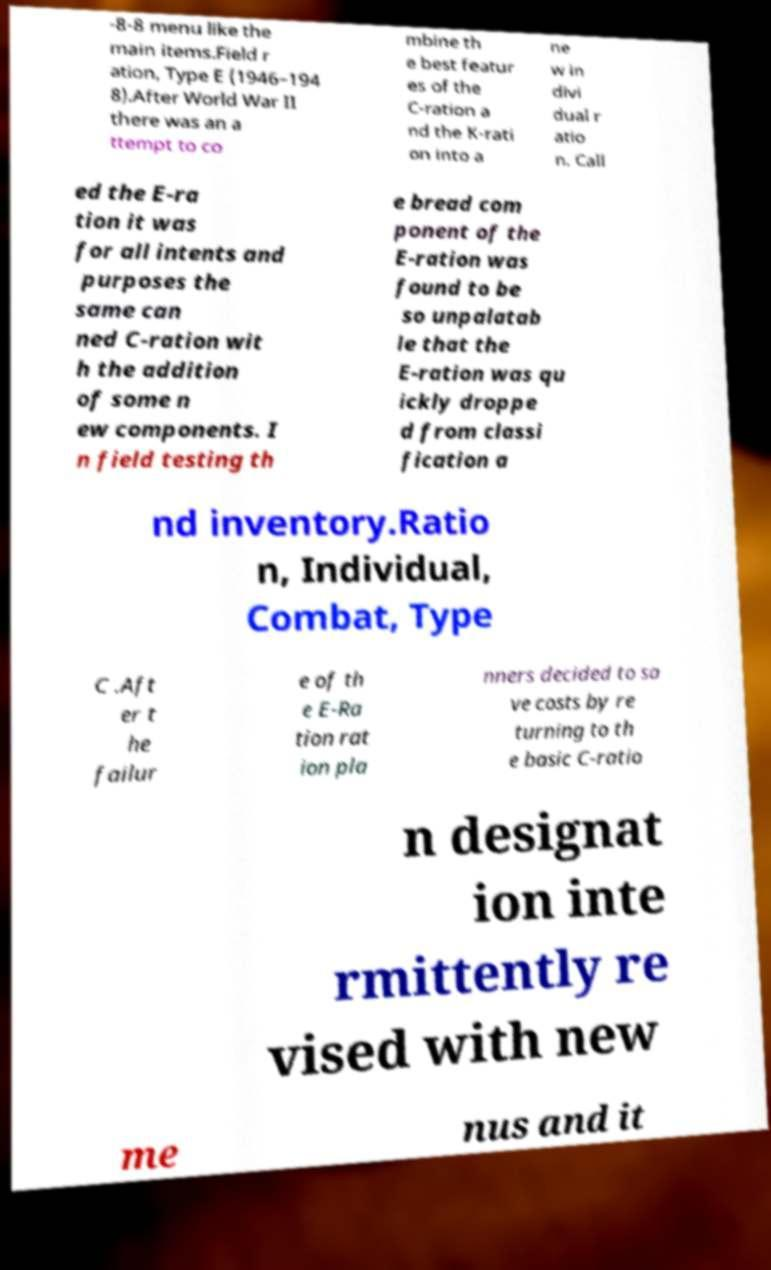I need the written content from this picture converted into text. Can you do that? -8-8 menu like the main items.Field r ation, Type E (1946–194 8).After World War II there was an a ttempt to co mbine th e best featur es of the C-ration a nd the K-rati on into a ne w in divi dual r atio n. Call ed the E-ra tion it was for all intents and purposes the same can ned C-ration wit h the addition of some n ew components. I n field testing th e bread com ponent of the E-ration was found to be so unpalatab le that the E-ration was qu ickly droppe d from classi fication a nd inventory.Ratio n, Individual, Combat, Type C .Aft er t he failur e of th e E-Ra tion rat ion pla nners decided to sa ve costs by re turning to th e basic C-ratio n designat ion inte rmittently re vised with new me nus and it 